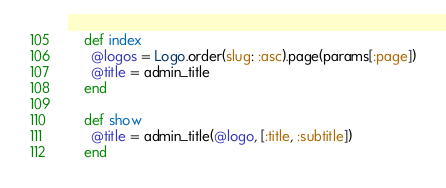Convert code to text. <code><loc_0><loc_0><loc_500><loc_500><_Ruby_>
    def index
      @logos = Logo.order(slug: :asc).page(params[:page])
      @title = admin_title
    end

    def show
      @title = admin_title(@logo, [:title, :subtitle])
    end
</code> 